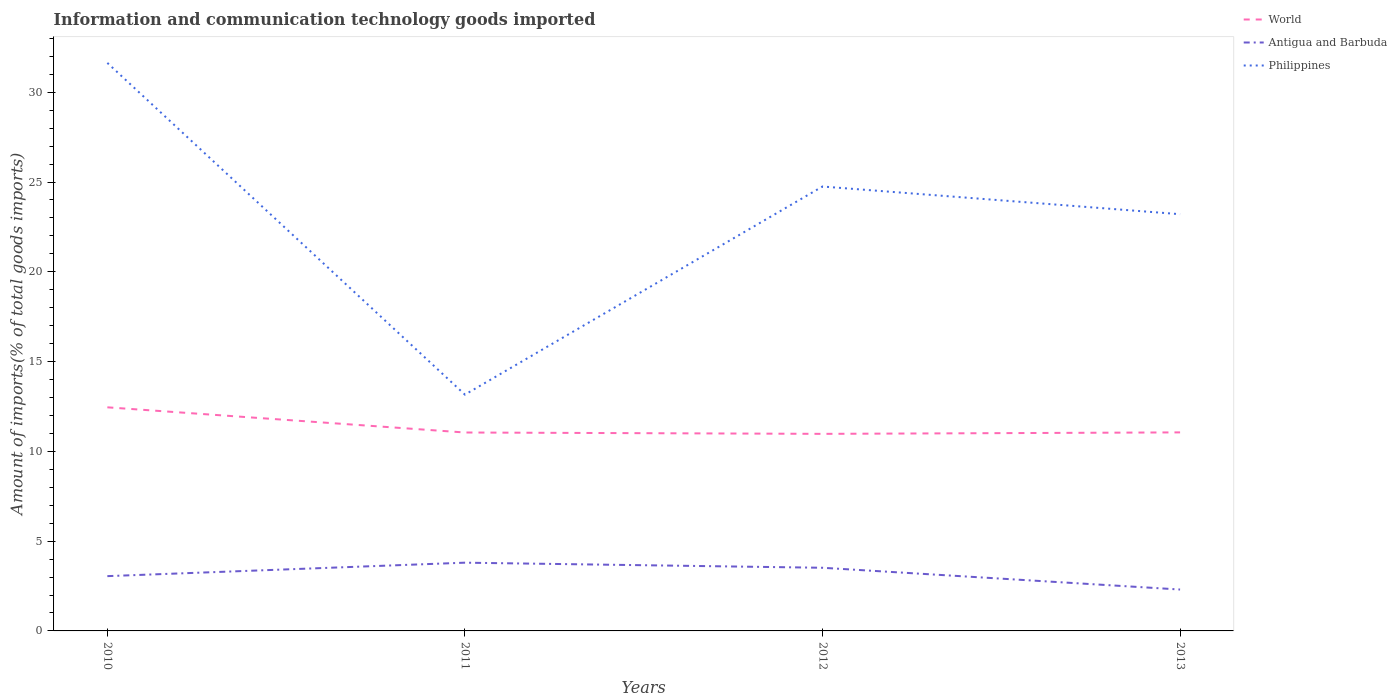Does the line corresponding to Antigua and Barbuda intersect with the line corresponding to Philippines?
Your answer should be compact. No. Is the number of lines equal to the number of legend labels?
Ensure brevity in your answer.  Yes. Across all years, what is the maximum amount of goods imported in World?
Offer a terse response. 10.97. In which year was the amount of goods imported in Antigua and Barbuda maximum?
Give a very brief answer. 2013. What is the total amount of goods imported in Antigua and Barbuda in the graph?
Provide a short and direct response. 1.21. What is the difference between the highest and the second highest amount of goods imported in Philippines?
Your answer should be compact. 18.47. What is the difference between the highest and the lowest amount of goods imported in World?
Your answer should be compact. 1. How many years are there in the graph?
Offer a very short reply. 4. What is the difference between two consecutive major ticks on the Y-axis?
Provide a short and direct response. 5. Are the values on the major ticks of Y-axis written in scientific E-notation?
Your answer should be compact. No. Does the graph contain any zero values?
Provide a short and direct response. No. What is the title of the graph?
Ensure brevity in your answer.  Information and communication technology goods imported. What is the label or title of the Y-axis?
Ensure brevity in your answer.  Amount of imports(% of total goods imports). What is the Amount of imports(% of total goods imports) in World in 2010?
Your answer should be compact. 12.45. What is the Amount of imports(% of total goods imports) of Antigua and Barbuda in 2010?
Keep it short and to the point. 3.05. What is the Amount of imports(% of total goods imports) of Philippines in 2010?
Your response must be concise. 31.63. What is the Amount of imports(% of total goods imports) in World in 2011?
Offer a terse response. 11.05. What is the Amount of imports(% of total goods imports) of Antigua and Barbuda in 2011?
Offer a very short reply. 3.8. What is the Amount of imports(% of total goods imports) of Philippines in 2011?
Keep it short and to the point. 13.16. What is the Amount of imports(% of total goods imports) in World in 2012?
Provide a succinct answer. 10.97. What is the Amount of imports(% of total goods imports) in Antigua and Barbuda in 2012?
Provide a succinct answer. 3.52. What is the Amount of imports(% of total goods imports) in Philippines in 2012?
Offer a terse response. 24.75. What is the Amount of imports(% of total goods imports) in World in 2013?
Make the answer very short. 11.06. What is the Amount of imports(% of total goods imports) of Antigua and Barbuda in 2013?
Your answer should be compact. 2.31. What is the Amount of imports(% of total goods imports) in Philippines in 2013?
Provide a short and direct response. 23.21. Across all years, what is the maximum Amount of imports(% of total goods imports) of World?
Your answer should be very brief. 12.45. Across all years, what is the maximum Amount of imports(% of total goods imports) of Antigua and Barbuda?
Offer a very short reply. 3.8. Across all years, what is the maximum Amount of imports(% of total goods imports) of Philippines?
Keep it short and to the point. 31.63. Across all years, what is the minimum Amount of imports(% of total goods imports) in World?
Provide a succinct answer. 10.97. Across all years, what is the minimum Amount of imports(% of total goods imports) of Antigua and Barbuda?
Your response must be concise. 2.31. Across all years, what is the minimum Amount of imports(% of total goods imports) of Philippines?
Provide a short and direct response. 13.16. What is the total Amount of imports(% of total goods imports) in World in the graph?
Give a very brief answer. 45.54. What is the total Amount of imports(% of total goods imports) of Antigua and Barbuda in the graph?
Your answer should be compact. 12.67. What is the total Amount of imports(% of total goods imports) in Philippines in the graph?
Offer a very short reply. 92.75. What is the difference between the Amount of imports(% of total goods imports) of World in 2010 and that in 2011?
Provide a succinct answer. 1.4. What is the difference between the Amount of imports(% of total goods imports) in Antigua and Barbuda in 2010 and that in 2011?
Offer a terse response. -0.75. What is the difference between the Amount of imports(% of total goods imports) of Philippines in 2010 and that in 2011?
Give a very brief answer. 18.47. What is the difference between the Amount of imports(% of total goods imports) of World in 2010 and that in 2012?
Keep it short and to the point. 1.48. What is the difference between the Amount of imports(% of total goods imports) in Antigua and Barbuda in 2010 and that in 2012?
Keep it short and to the point. -0.47. What is the difference between the Amount of imports(% of total goods imports) in Philippines in 2010 and that in 2012?
Your answer should be compact. 6.88. What is the difference between the Amount of imports(% of total goods imports) of World in 2010 and that in 2013?
Offer a terse response. 1.4. What is the difference between the Amount of imports(% of total goods imports) in Antigua and Barbuda in 2010 and that in 2013?
Your response must be concise. 0.75. What is the difference between the Amount of imports(% of total goods imports) of Philippines in 2010 and that in 2013?
Give a very brief answer. 8.43. What is the difference between the Amount of imports(% of total goods imports) of World in 2011 and that in 2012?
Offer a very short reply. 0.08. What is the difference between the Amount of imports(% of total goods imports) of Antigua and Barbuda in 2011 and that in 2012?
Provide a short and direct response. 0.28. What is the difference between the Amount of imports(% of total goods imports) of Philippines in 2011 and that in 2012?
Keep it short and to the point. -11.59. What is the difference between the Amount of imports(% of total goods imports) of World in 2011 and that in 2013?
Provide a short and direct response. -0.01. What is the difference between the Amount of imports(% of total goods imports) in Antigua and Barbuda in 2011 and that in 2013?
Provide a succinct answer. 1.5. What is the difference between the Amount of imports(% of total goods imports) in Philippines in 2011 and that in 2013?
Your response must be concise. -10.05. What is the difference between the Amount of imports(% of total goods imports) in World in 2012 and that in 2013?
Provide a short and direct response. -0.08. What is the difference between the Amount of imports(% of total goods imports) in Antigua and Barbuda in 2012 and that in 2013?
Your response must be concise. 1.21. What is the difference between the Amount of imports(% of total goods imports) in Philippines in 2012 and that in 2013?
Provide a succinct answer. 1.54. What is the difference between the Amount of imports(% of total goods imports) in World in 2010 and the Amount of imports(% of total goods imports) in Antigua and Barbuda in 2011?
Your answer should be very brief. 8.65. What is the difference between the Amount of imports(% of total goods imports) of World in 2010 and the Amount of imports(% of total goods imports) of Philippines in 2011?
Offer a very short reply. -0.71. What is the difference between the Amount of imports(% of total goods imports) in Antigua and Barbuda in 2010 and the Amount of imports(% of total goods imports) in Philippines in 2011?
Your answer should be compact. -10.11. What is the difference between the Amount of imports(% of total goods imports) of World in 2010 and the Amount of imports(% of total goods imports) of Antigua and Barbuda in 2012?
Your answer should be compact. 8.94. What is the difference between the Amount of imports(% of total goods imports) in World in 2010 and the Amount of imports(% of total goods imports) in Philippines in 2012?
Make the answer very short. -12.3. What is the difference between the Amount of imports(% of total goods imports) of Antigua and Barbuda in 2010 and the Amount of imports(% of total goods imports) of Philippines in 2012?
Offer a very short reply. -21.7. What is the difference between the Amount of imports(% of total goods imports) of World in 2010 and the Amount of imports(% of total goods imports) of Antigua and Barbuda in 2013?
Your answer should be compact. 10.15. What is the difference between the Amount of imports(% of total goods imports) in World in 2010 and the Amount of imports(% of total goods imports) in Philippines in 2013?
Ensure brevity in your answer.  -10.76. What is the difference between the Amount of imports(% of total goods imports) of Antigua and Barbuda in 2010 and the Amount of imports(% of total goods imports) of Philippines in 2013?
Make the answer very short. -20.16. What is the difference between the Amount of imports(% of total goods imports) of World in 2011 and the Amount of imports(% of total goods imports) of Antigua and Barbuda in 2012?
Provide a succinct answer. 7.53. What is the difference between the Amount of imports(% of total goods imports) in World in 2011 and the Amount of imports(% of total goods imports) in Philippines in 2012?
Provide a short and direct response. -13.7. What is the difference between the Amount of imports(% of total goods imports) of Antigua and Barbuda in 2011 and the Amount of imports(% of total goods imports) of Philippines in 2012?
Make the answer very short. -20.95. What is the difference between the Amount of imports(% of total goods imports) in World in 2011 and the Amount of imports(% of total goods imports) in Antigua and Barbuda in 2013?
Provide a short and direct response. 8.75. What is the difference between the Amount of imports(% of total goods imports) of World in 2011 and the Amount of imports(% of total goods imports) of Philippines in 2013?
Offer a very short reply. -12.16. What is the difference between the Amount of imports(% of total goods imports) of Antigua and Barbuda in 2011 and the Amount of imports(% of total goods imports) of Philippines in 2013?
Your response must be concise. -19.41. What is the difference between the Amount of imports(% of total goods imports) of World in 2012 and the Amount of imports(% of total goods imports) of Antigua and Barbuda in 2013?
Offer a very short reply. 8.67. What is the difference between the Amount of imports(% of total goods imports) of World in 2012 and the Amount of imports(% of total goods imports) of Philippines in 2013?
Ensure brevity in your answer.  -12.23. What is the difference between the Amount of imports(% of total goods imports) in Antigua and Barbuda in 2012 and the Amount of imports(% of total goods imports) in Philippines in 2013?
Ensure brevity in your answer.  -19.69. What is the average Amount of imports(% of total goods imports) in World per year?
Keep it short and to the point. 11.38. What is the average Amount of imports(% of total goods imports) of Antigua and Barbuda per year?
Your answer should be very brief. 3.17. What is the average Amount of imports(% of total goods imports) in Philippines per year?
Give a very brief answer. 23.19. In the year 2010, what is the difference between the Amount of imports(% of total goods imports) of World and Amount of imports(% of total goods imports) of Antigua and Barbuda?
Offer a very short reply. 9.4. In the year 2010, what is the difference between the Amount of imports(% of total goods imports) of World and Amount of imports(% of total goods imports) of Philippines?
Provide a short and direct response. -19.18. In the year 2010, what is the difference between the Amount of imports(% of total goods imports) in Antigua and Barbuda and Amount of imports(% of total goods imports) in Philippines?
Make the answer very short. -28.58. In the year 2011, what is the difference between the Amount of imports(% of total goods imports) of World and Amount of imports(% of total goods imports) of Antigua and Barbuda?
Offer a terse response. 7.25. In the year 2011, what is the difference between the Amount of imports(% of total goods imports) of World and Amount of imports(% of total goods imports) of Philippines?
Provide a succinct answer. -2.11. In the year 2011, what is the difference between the Amount of imports(% of total goods imports) of Antigua and Barbuda and Amount of imports(% of total goods imports) of Philippines?
Offer a terse response. -9.36. In the year 2012, what is the difference between the Amount of imports(% of total goods imports) of World and Amount of imports(% of total goods imports) of Antigua and Barbuda?
Make the answer very short. 7.46. In the year 2012, what is the difference between the Amount of imports(% of total goods imports) in World and Amount of imports(% of total goods imports) in Philippines?
Ensure brevity in your answer.  -13.78. In the year 2012, what is the difference between the Amount of imports(% of total goods imports) of Antigua and Barbuda and Amount of imports(% of total goods imports) of Philippines?
Provide a short and direct response. -21.23. In the year 2013, what is the difference between the Amount of imports(% of total goods imports) in World and Amount of imports(% of total goods imports) in Antigua and Barbuda?
Make the answer very short. 8.75. In the year 2013, what is the difference between the Amount of imports(% of total goods imports) of World and Amount of imports(% of total goods imports) of Philippines?
Give a very brief answer. -12.15. In the year 2013, what is the difference between the Amount of imports(% of total goods imports) in Antigua and Barbuda and Amount of imports(% of total goods imports) in Philippines?
Keep it short and to the point. -20.9. What is the ratio of the Amount of imports(% of total goods imports) in World in 2010 to that in 2011?
Your answer should be compact. 1.13. What is the ratio of the Amount of imports(% of total goods imports) in Antigua and Barbuda in 2010 to that in 2011?
Offer a very short reply. 0.8. What is the ratio of the Amount of imports(% of total goods imports) of Philippines in 2010 to that in 2011?
Offer a very short reply. 2.4. What is the ratio of the Amount of imports(% of total goods imports) in World in 2010 to that in 2012?
Keep it short and to the point. 1.13. What is the ratio of the Amount of imports(% of total goods imports) in Antigua and Barbuda in 2010 to that in 2012?
Provide a succinct answer. 0.87. What is the ratio of the Amount of imports(% of total goods imports) of Philippines in 2010 to that in 2012?
Make the answer very short. 1.28. What is the ratio of the Amount of imports(% of total goods imports) of World in 2010 to that in 2013?
Your answer should be compact. 1.13. What is the ratio of the Amount of imports(% of total goods imports) in Antigua and Barbuda in 2010 to that in 2013?
Keep it short and to the point. 1.32. What is the ratio of the Amount of imports(% of total goods imports) in Philippines in 2010 to that in 2013?
Offer a terse response. 1.36. What is the ratio of the Amount of imports(% of total goods imports) of World in 2011 to that in 2012?
Your answer should be very brief. 1.01. What is the ratio of the Amount of imports(% of total goods imports) of Antigua and Barbuda in 2011 to that in 2012?
Offer a very short reply. 1.08. What is the ratio of the Amount of imports(% of total goods imports) of Philippines in 2011 to that in 2012?
Provide a succinct answer. 0.53. What is the ratio of the Amount of imports(% of total goods imports) in World in 2011 to that in 2013?
Ensure brevity in your answer.  1. What is the ratio of the Amount of imports(% of total goods imports) in Antigua and Barbuda in 2011 to that in 2013?
Give a very brief answer. 1.65. What is the ratio of the Amount of imports(% of total goods imports) in Philippines in 2011 to that in 2013?
Offer a very short reply. 0.57. What is the ratio of the Amount of imports(% of total goods imports) of Antigua and Barbuda in 2012 to that in 2013?
Keep it short and to the point. 1.53. What is the ratio of the Amount of imports(% of total goods imports) of Philippines in 2012 to that in 2013?
Offer a very short reply. 1.07. What is the difference between the highest and the second highest Amount of imports(% of total goods imports) of World?
Your response must be concise. 1.4. What is the difference between the highest and the second highest Amount of imports(% of total goods imports) in Antigua and Barbuda?
Ensure brevity in your answer.  0.28. What is the difference between the highest and the second highest Amount of imports(% of total goods imports) of Philippines?
Make the answer very short. 6.88. What is the difference between the highest and the lowest Amount of imports(% of total goods imports) of World?
Make the answer very short. 1.48. What is the difference between the highest and the lowest Amount of imports(% of total goods imports) in Antigua and Barbuda?
Offer a terse response. 1.5. What is the difference between the highest and the lowest Amount of imports(% of total goods imports) of Philippines?
Give a very brief answer. 18.47. 